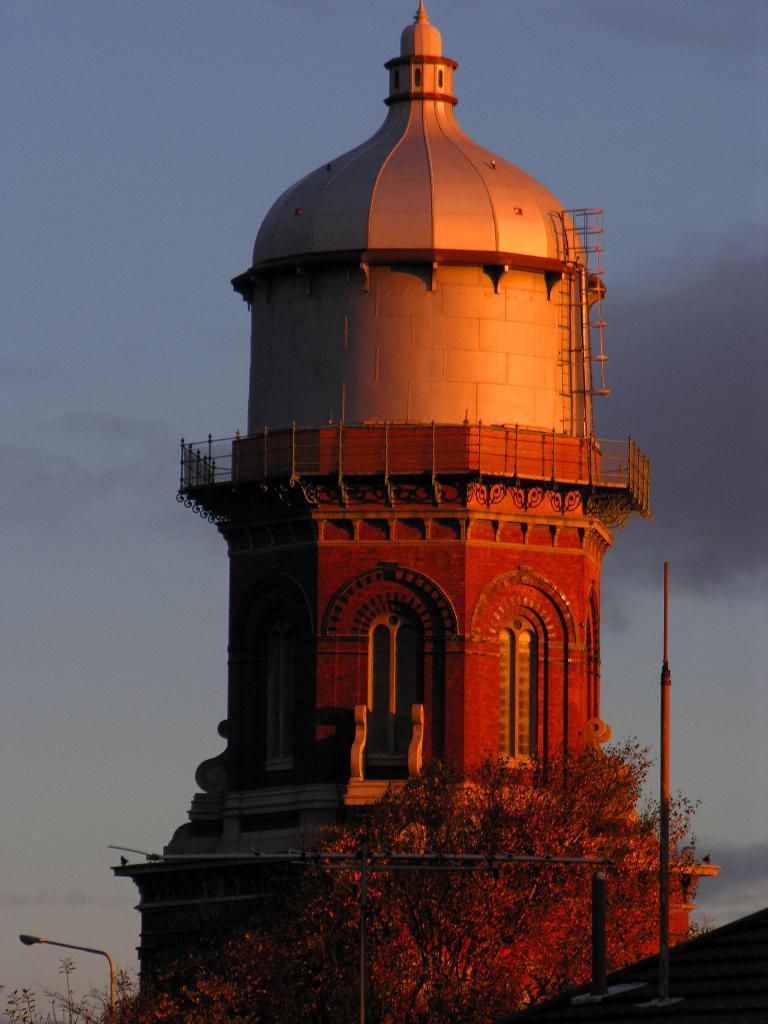In one or two sentences, can you explain what this image depicts? Here I can see a construction which looks like a minar. At the bottom of the image there is a tree. In the background, I can see the sky. 